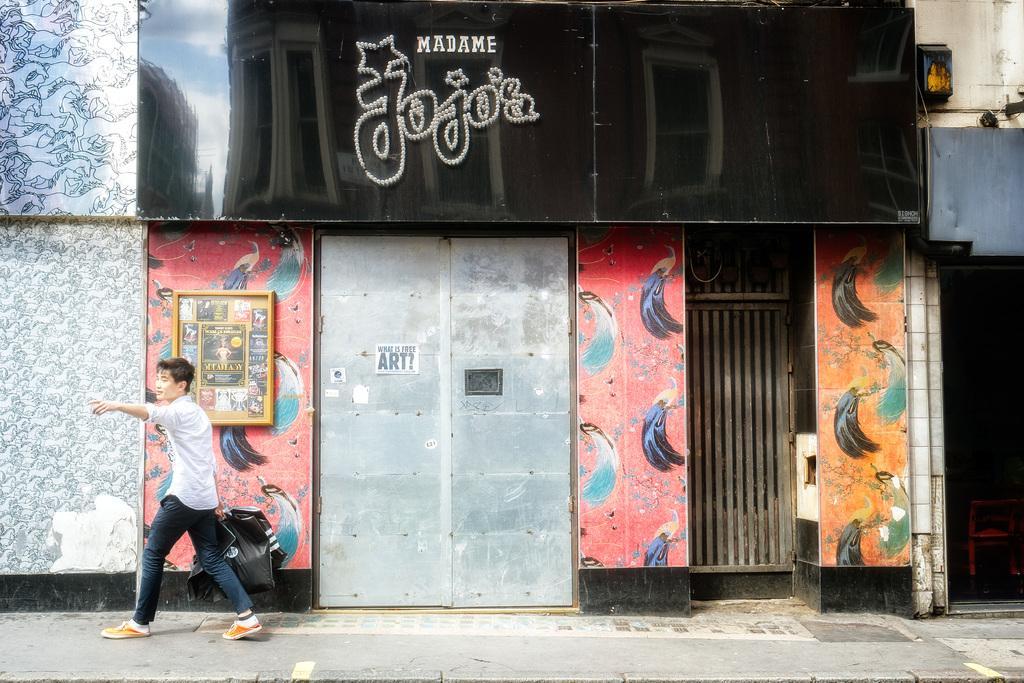Could you give a brief overview of what you see in this image? In this picture I can see a person holding covers and walking in front of the buildings, side we can see painted walls and also I can see a board with text. 